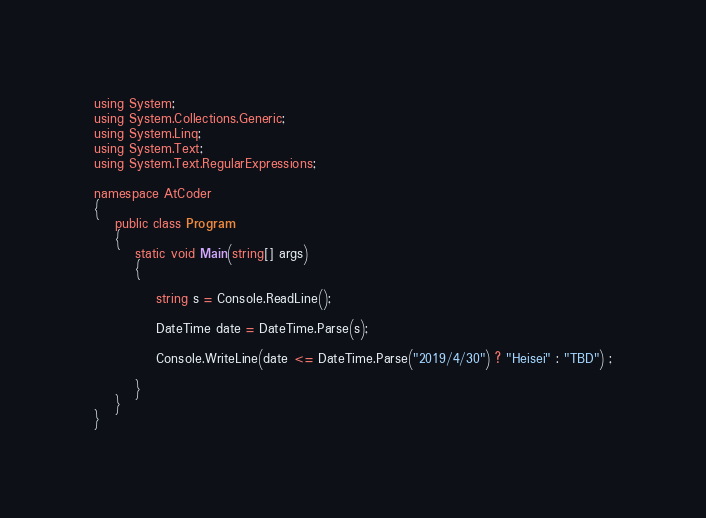<code> <loc_0><loc_0><loc_500><loc_500><_C#_>using System;
using System.Collections.Generic;
using System.Linq;
using System.Text;
using System.Text.RegularExpressions;

namespace AtCoder
{
	public class Program
	{
		static void Main(string[] args)
		{

			string s = Console.ReadLine();

			DateTime date = DateTime.Parse(s);

			Console.WriteLine(date <= DateTime.Parse("2019/4/30") ? "Heisei" : "TBD") ;

		}
	}
}
</code> 